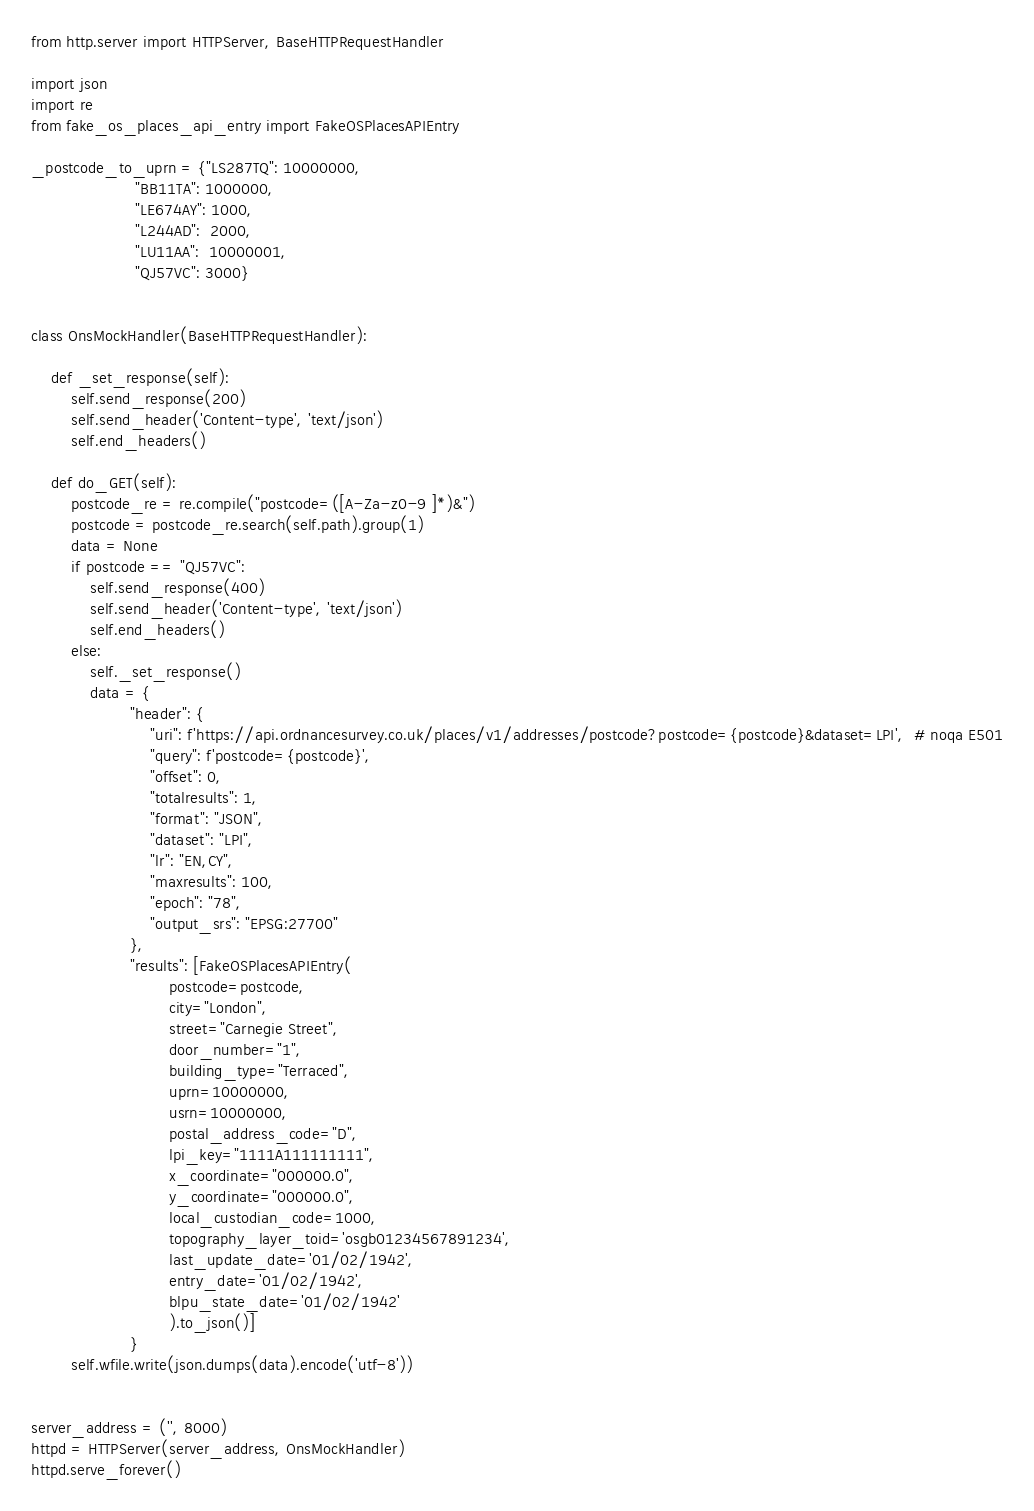<code> <loc_0><loc_0><loc_500><loc_500><_Python_>from http.server import HTTPServer, BaseHTTPRequestHandler

import json
import re
from fake_os_places_api_entry import FakeOSPlacesAPIEntry

_postcode_to_uprn = {"LS287TQ": 10000000,
                     "BB11TA": 1000000,
                     "LE674AY": 1000,
                     "L244AD":  2000,
                     "LU11AA":  10000001,
                     "QJ57VC": 3000}


class OnsMockHandler(BaseHTTPRequestHandler):

    def _set_response(self):
        self.send_response(200)
        self.send_header('Content-type', 'text/json')
        self.end_headers()

    def do_GET(self):
        postcode_re = re.compile("postcode=([A-Za-z0-9 ]*)&")
        postcode = postcode_re.search(self.path).group(1)
        data = None
        if postcode == "QJ57VC":
            self.send_response(400)
            self.send_header('Content-type', 'text/json')
            self.end_headers()
        else:
            self._set_response()
            data = {
                    "header": {
                        "uri": f'https://api.ordnancesurvey.co.uk/places/v1/addresses/postcode?postcode={postcode}&dataset=LPI',  # noqa E501
                        "query": f'postcode={postcode}',
                        "offset": 0,
                        "totalresults": 1,
                        "format": "JSON",
                        "dataset": "LPI",
                        "lr": "EN,CY",
                        "maxresults": 100,
                        "epoch": "78",
                        "output_srs": "EPSG:27700"
                    },
                    "results": [FakeOSPlacesAPIEntry(
                            postcode=postcode,
                            city="London",
                            street="Carnegie Street",
                            door_number="1",
                            building_type="Terraced",
                            uprn=10000000,
                            usrn=10000000,
                            postal_address_code="D",
                            lpi_key="1111A111111111",
                            x_coordinate="000000.0",
                            y_coordinate="000000.0",
                            local_custodian_code=1000,
                            topography_layer_toid='osgb01234567891234',
                            last_update_date='01/02/1942',
                            entry_date='01/02/1942',
                            blpu_state_date='01/02/1942'
                            ).to_json()]
                    }
        self.wfile.write(json.dumps(data).encode('utf-8'))


server_address = ('', 8000)
httpd = HTTPServer(server_address, OnsMockHandler)
httpd.serve_forever()
</code> 